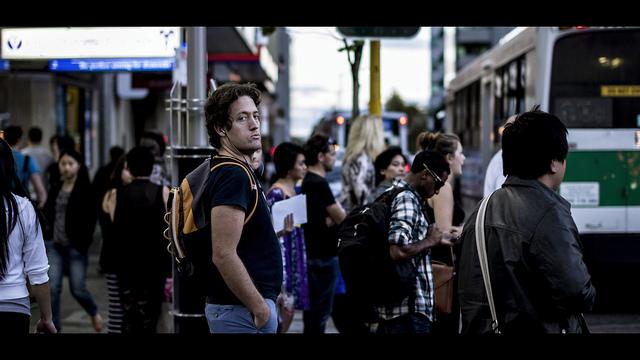Is the background blurry?
Quick response, please. Yes. Is everyone on a cell phone?
Answer briefly. No. Would a grown-up person use such suitcases?
Write a very short answer. Yes. How many bald men in this picture?
Answer briefly. 0. Is it a sunny day?
Be succinct. No. Did she just receive shocking news?
Keep it brief. No. How many people are in the picture?
Be succinct. 18. What color backpack does the man looking at the camera have?
Short answer required. Blue and yellow. What color hair does the majority of the people have?
Give a very brief answer. Black. 